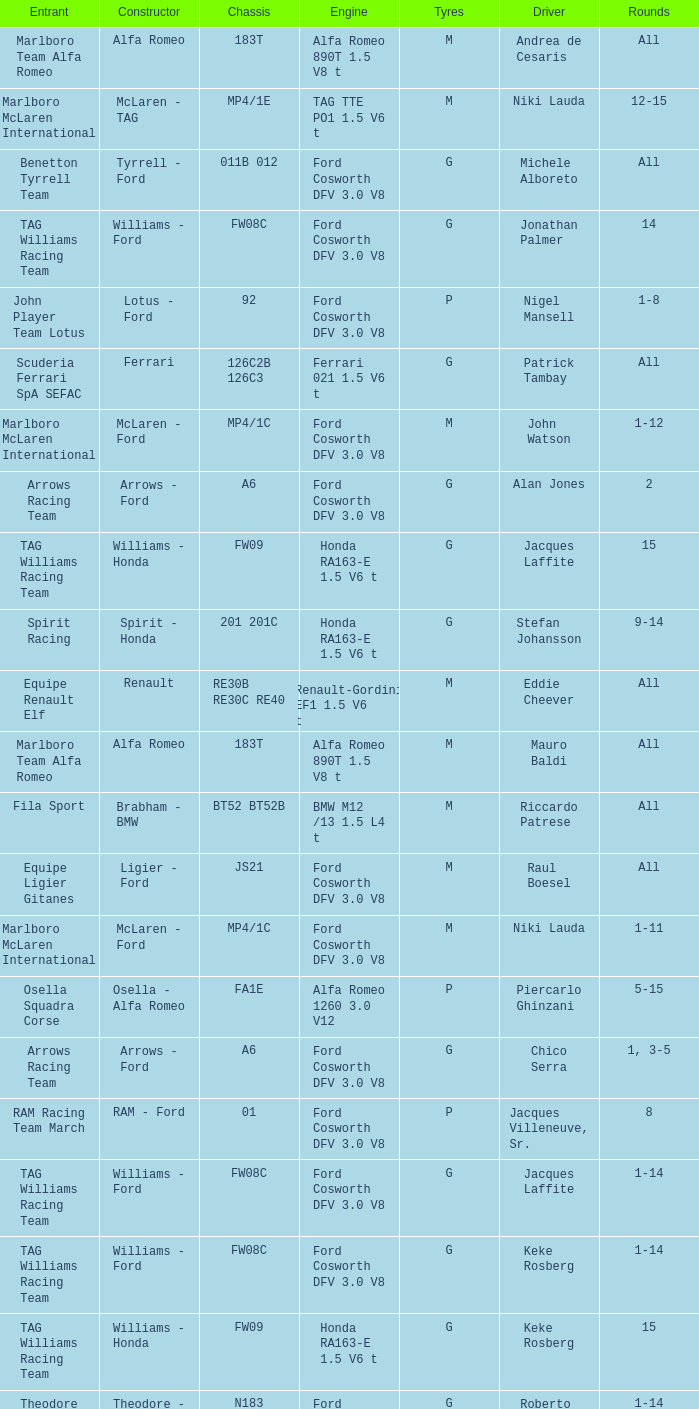Who is the Constructor for driver Piercarlo Ghinzani and a Ford cosworth dfv 3.0 v8 engine? Osella - Ford. 